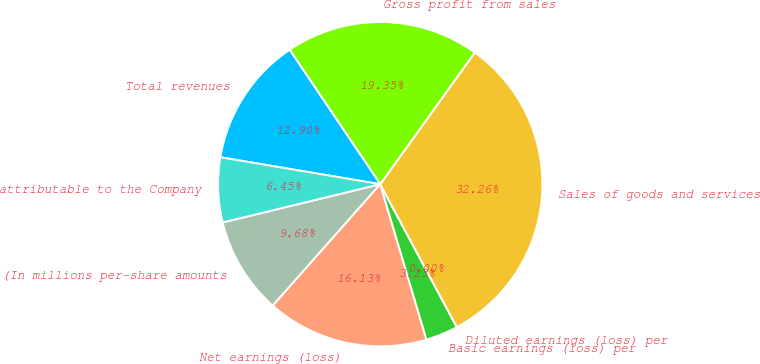Convert chart to OTSL. <chart><loc_0><loc_0><loc_500><loc_500><pie_chart><fcel>(In millions per-share amounts<fcel>Net earnings (loss)<fcel>Basic earnings (loss) per<fcel>Diluted earnings (loss) per<fcel>Sales of goods and services<fcel>Gross profit from sales<fcel>Total revenues<fcel>attributable to the Company<nl><fcel>9.68%<fcel>16.13%<fcel>3.23%<fcel>0.0%<fcel>32.26%<fcel>19.35%<fcel>12.9%<fcel>6.45%<nl></chart> 